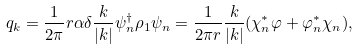Convert formula to latex. <formula><loc_0><loc_0><loc_500><loc_500>q _ { k } = \frac { 1 } { 2 \pi } r \alpha \delta \frac { k } { | k | } \psi _ { n } ^ { \dagger } \rho _ { 1 } \psi _ { n } = \frac { 1 } { 2 \pi r } \frac { k } { | k | } ( \chi _ { n } ^ { * } \varphi + \varphi _ { n } ^ { * } \chi _ { n } ) ,</formula> 